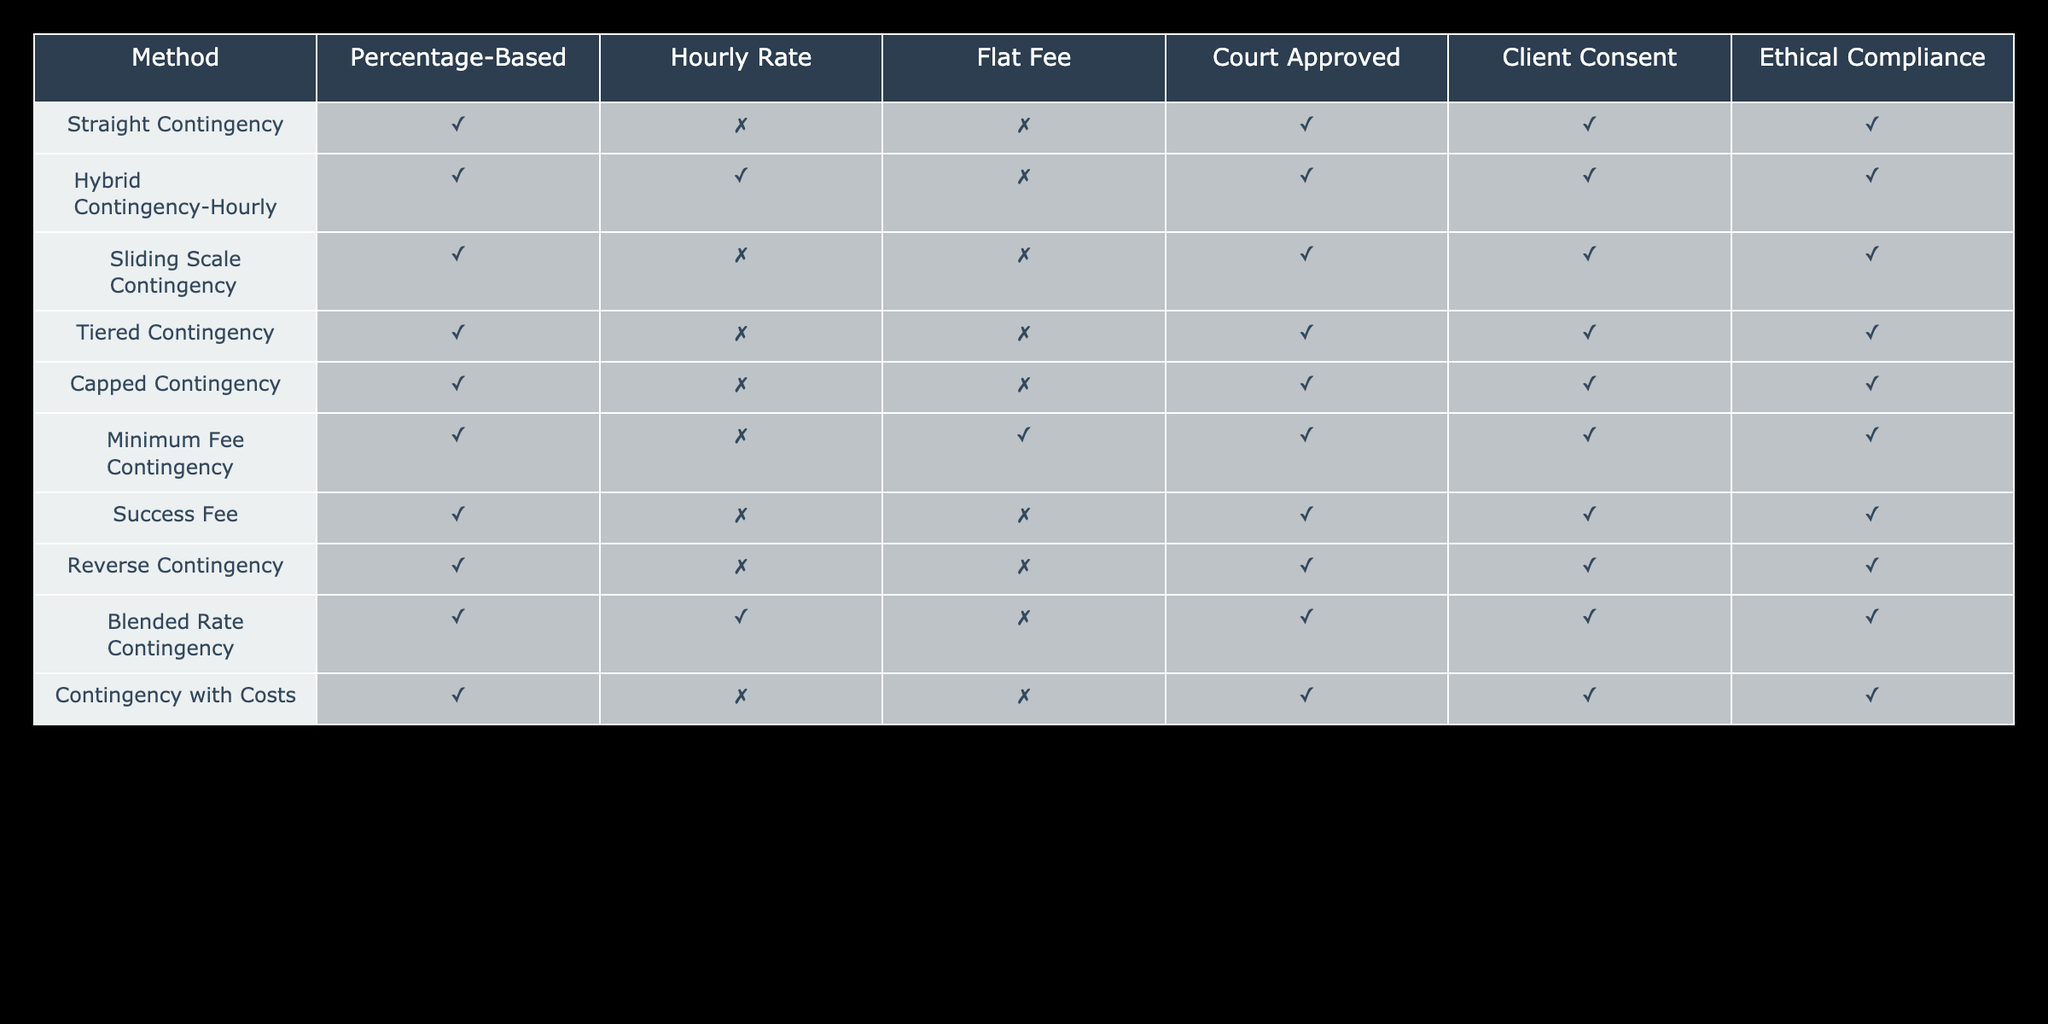What fee calculation methods are based on a percentage? The table indicates that all methods listed have 'TRUE' under the Percentage-Based column, meaning they all can be calculated based on a percentage.
Answer: All methods Which methods are court-approved? By examining the table, the methods that have 'TRUE' under the Court Approved column are Straight Contingency, Hybrid Contingency-Hourly, Sliding Scale Contingency, Tiered Contingency, Capped Contingency, Minimum Fee Contingency, Success Fee, Reverse Contingency, Blended Rate Contingency, and Contingency with Costs.
Answer: 10 methods Is the Sliding Scale Contingency ethical? Looking at the Ethical Compliance column, Sliding Scale Contingency has 'TRUE', indicating it complies with ethical standards.
Answer: Yes How many methods utilize a flat fee? The table shows only Minimum Fee Contingency as the method that utilizes a flat fee, indicated by 'TRUE' in the Flat Fee column.
Answer: 1 method Do any methods operate under both hourly rate and percentage-based calculations? The only method that has 'TRUE' under both the Hourly Rate and Percentage-Based columns is Hybrid Contingency-Hourly, meaning it can use both calculation methods.
Answer: Yes Which methods require client consent? The methods that require client consent, as indicated by 'TRUE' in the Client Consent column, include all methods listed in the table, confirming client consent is needed for all.
Answer: All methods List the methods that do not use an hourly rate. By checking the Hourly Rate column, the methods that show 'FALSE' and therefore do not use an hourly rate are: Straight Contingency, Sliding Scale Contingency, Tiered Contingency, Capped Contingency, Success Fee, Reverse Contingency, and Contingency with Costs.
Answer: 7 methods How many methods are both percentage-based and ethically compliant? To find the methods that are both percentage-based and ethically compliant, we see that all methods have 'TRUE' in both the Percentage-Based and Ethical Compliance columns, meaning all methods fit this category.
Answer: 10 methods Which is the only method that incorporates both a flat fee and falls under percentage-based calculation? The only method listed that falls into both 'TRUE' for Flat Fee and Percentage-Based is Minimum Fee Contingency, making it unique in this aspect.
Answer: Minimum Fee Contingency 